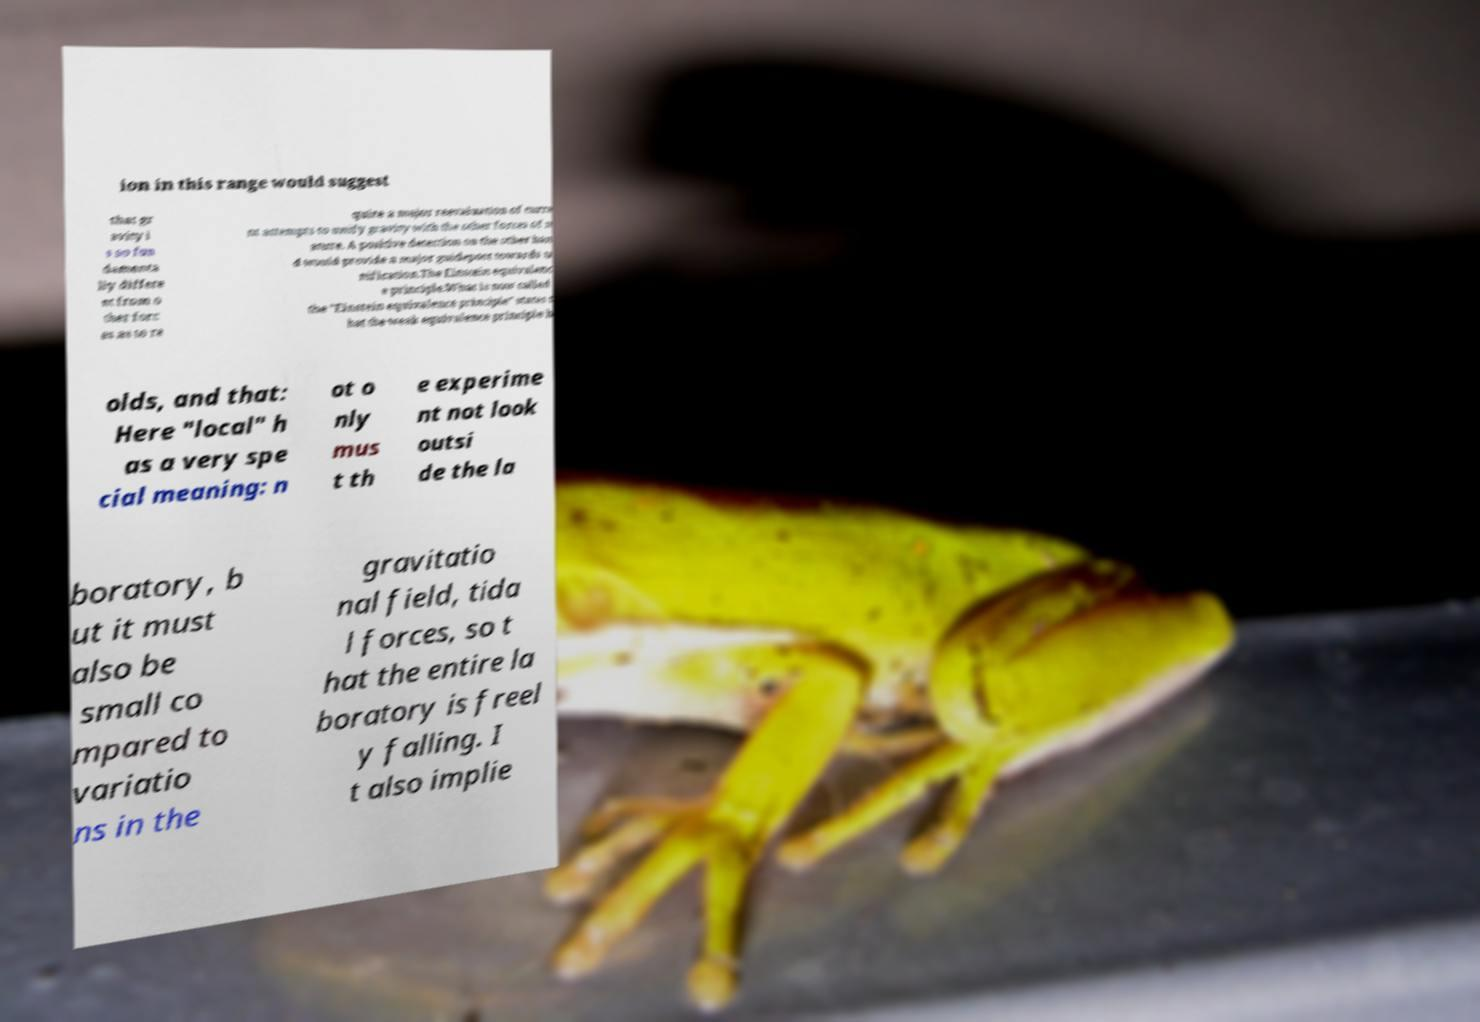Please identify and transcribe the text found in this image. ion in this range would suggest that gr avity i s so fun damenta lly differe nt from o ther forc es as to re quire a major reevaluation of curre nt attempts to unify gravity with the other forces of n ature. A positive detection on the other han d would provide a major guidepost towards u nification.The Einstein equivalenc e principle.What is now called the "Einstein equivalence principle" states t hat the weak equivalence principle h olds, and that: Here "local" h as a very spe cial meaning: n ot o nly mus t th e experime nt not look outsi de the la boratory, b ut it must also be small co mpared to variatio ns in the gravitatio nal field, tida l forces, so t hat the entire la boratory is freel y falling. I t also implie 